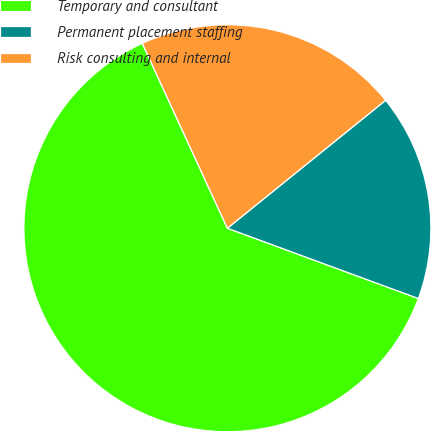Convert chart. <chart><loc_0><loc_0><loc_500><loc_500><pie_chart><fcel>Temporary and consultant<fcel>Permanent placement staffing<fcel>Risk consulting and internal<nl><fcel>62.52%<fcel>16.43%<fcel>21.04%<nl></chart> 